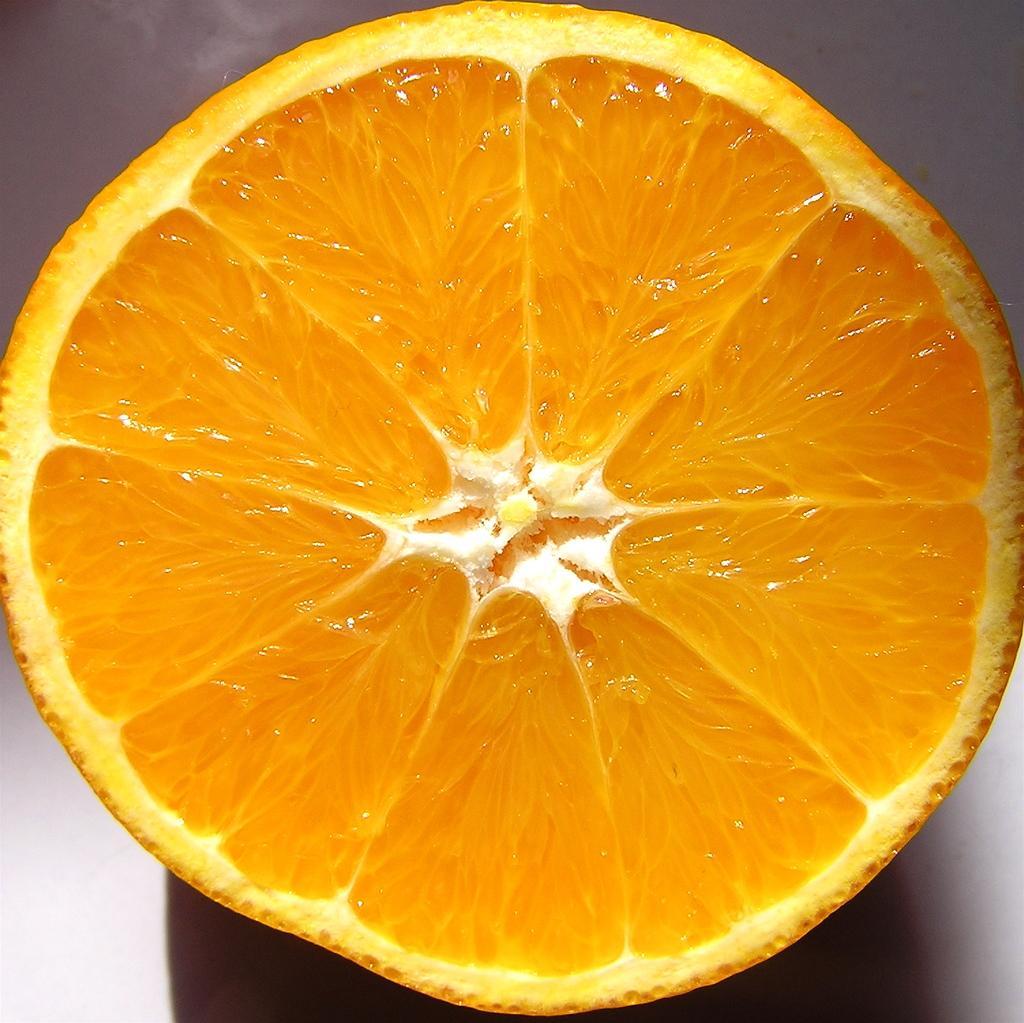How would you summarize this image in a sentence or two? In this image we can see an orange is cut and kept on the white color surface. 